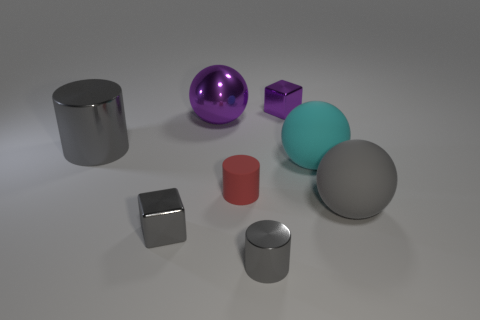Subtract all big gray cylinders. How many cylinders are left? 2 Subtract all purple cubes. How many cubes are left? 1 Subtract all cubes. How many objects are left? 6 Subtract all blue blocks. How many green spheres are left? 0 Subtract all big yellow matte things. Subtract all big gray cylinders. How many objects are left? 7 Add 3 red matte cylinders. How many red matte cylinders are left? 4 Add 8 tiny brown matte things. How many tiny brown matte things exist? 8 Add 1 large purple metallic balls. How many objects exist? 9 Subtract 0 yellow balls. How many objects are left? 8 Subtract 1 cubes. How many cubes are left? 1 